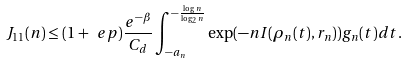<formula> <loc_0><loc_0><loc_500><loc_500>J _ { 1 1 } ( n ) \leq ( 1 + \ e p ) \frac { e ^ { - \beta } } { C _ { d } } \int _ { - a _ { n } } ^ { - \frac { \log \, n } { \log _ { 2 } n } } \exp ( - n I ( \rho _ { n } ( t ) , r _ { n } ) ) g _ { n } ( t ) d t .</formula> 